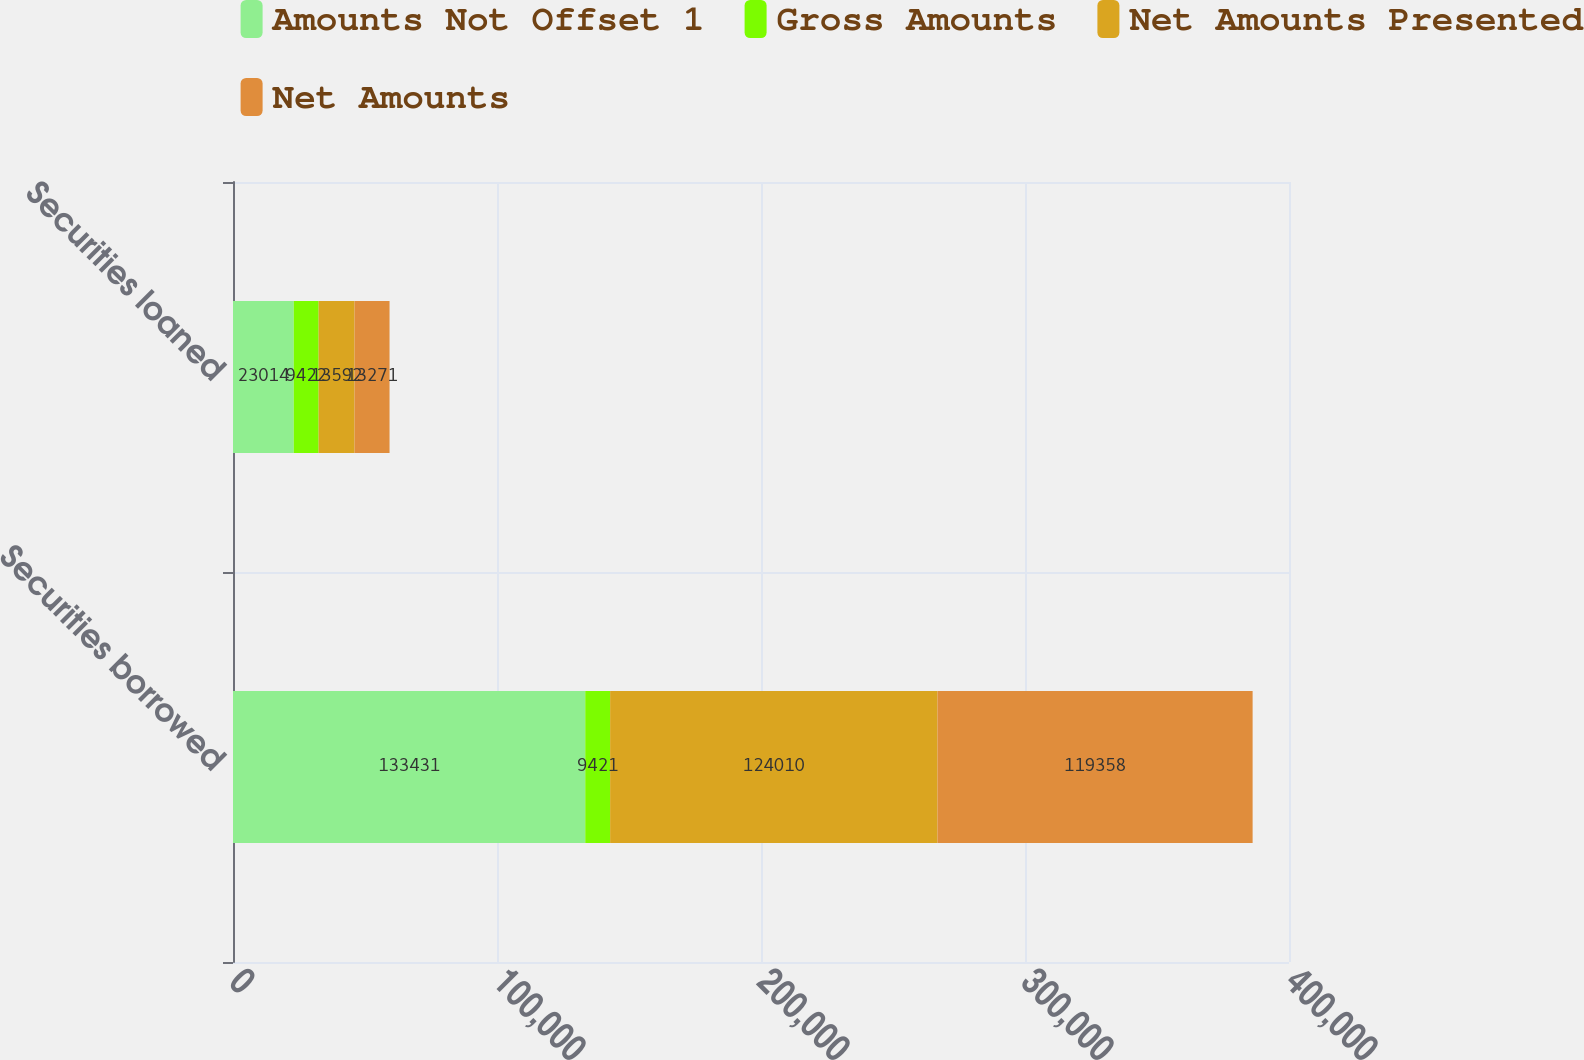<chart> <loc_0><loc_0><loc_500><loc_500><stacked_bar_chart><ecel><fcel>Securities borrowed<fcel>Securities loaned<nl><fcel>Amounts Not Offset 1<fcel>133431<fcel>23014<nl><fcel>Gross Amounts<fcel>9421<fcel>9422<nl><fcel>Net Amounts Presented<fcel>124010<fcel>13592<nl><fcel>Net Amounts<fcel>119358<fcel>13271<nl></chart> 